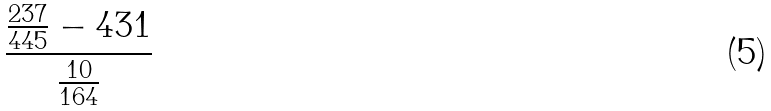Convert formula to latex. <formula><loc_0><loc_0><loc_500><loc_500>\frac { \frac { 2 3 7 } { 4 4 5 } - 4 3 1 } { \frac { 1 0 } { 1 6 4 } }</formula> 